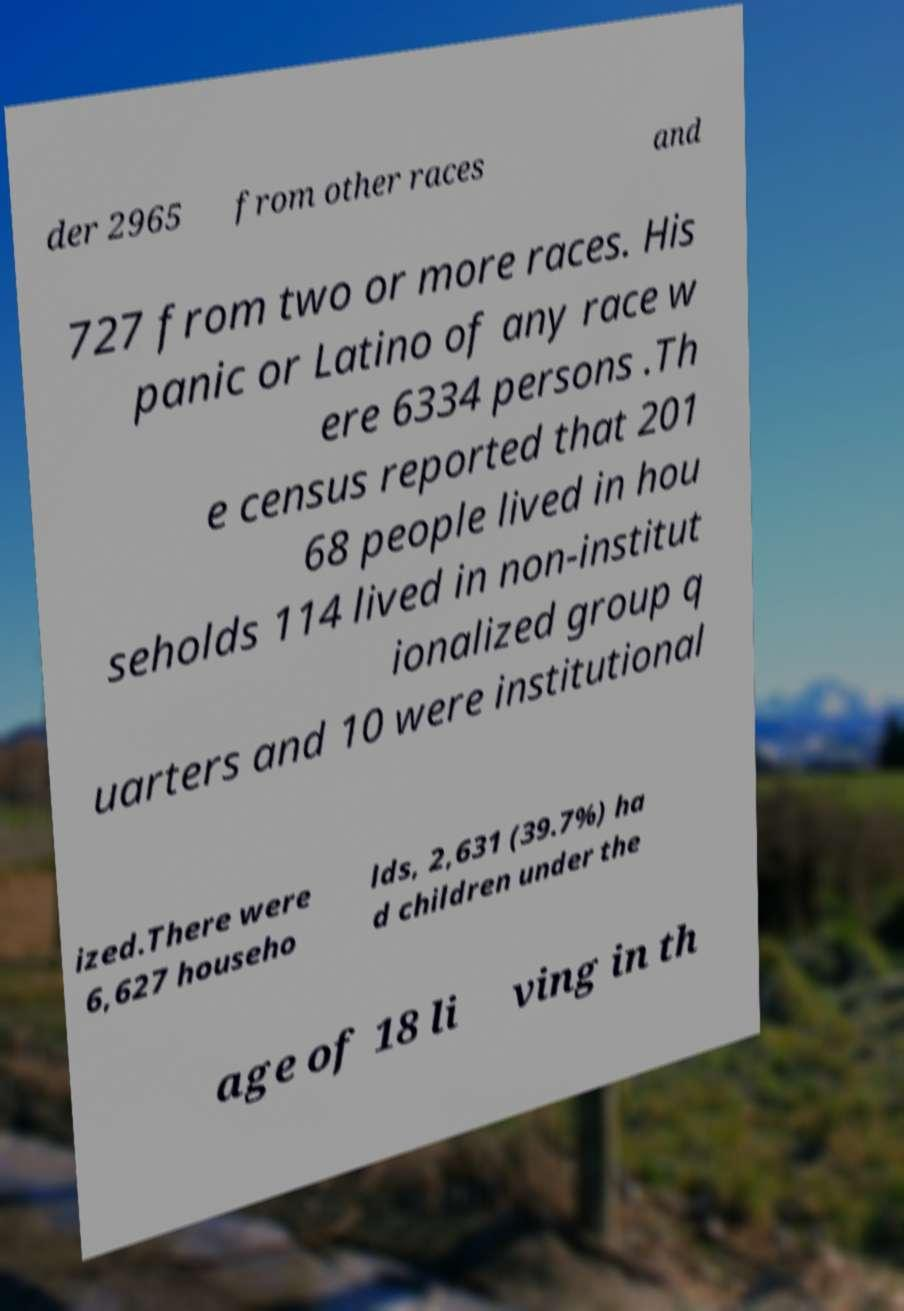What messages or text are displayed in this image? I need them in a readable, typed format. der 2965 from other races and 727 from two or more races. His panic or Latino of any race w ere 6334 persons .Th e census reported that 201 68 people lived in hou seholds 114 lived in non-institut ionalized group q uarters and 10 were institutional ized.There were 6,627 househo lds, 2,631 (39.7%) ha d children under the age of 18 li ving in th 